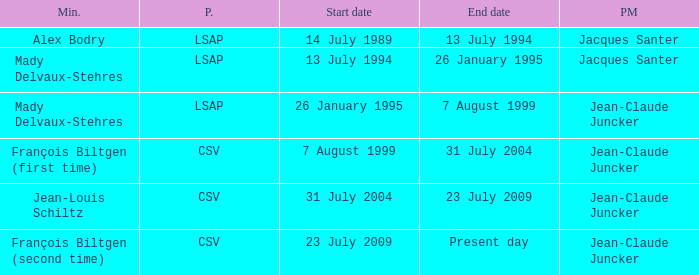Can you identify the minister from the csv party whose term has a contemporary end date? François Biltgen (second time). 